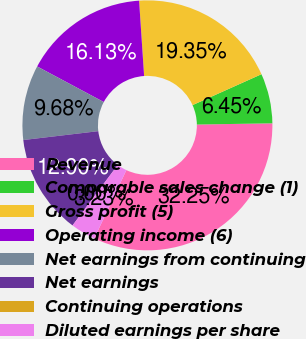Convert chart. <chart><loc_0><loc_0><loc_500><loc_500><pie_chart><fcel>Revenue<fcel>Comparable sales change (1)<fcel>Gross profit (5)<fcel>Operating income (6)<fcel>Net earnings from continuing<fcel>Net earnings<fcel>Continuing operations<fcel>Diluted earnings per share<nl><fcel>32.25%<fcel>6.45%<fcel>19.35%<fcel>16.13%<fcel>9.68%<fcel>12.9%<fcel>0.0%<fcel>3.23%<nl></chart> 